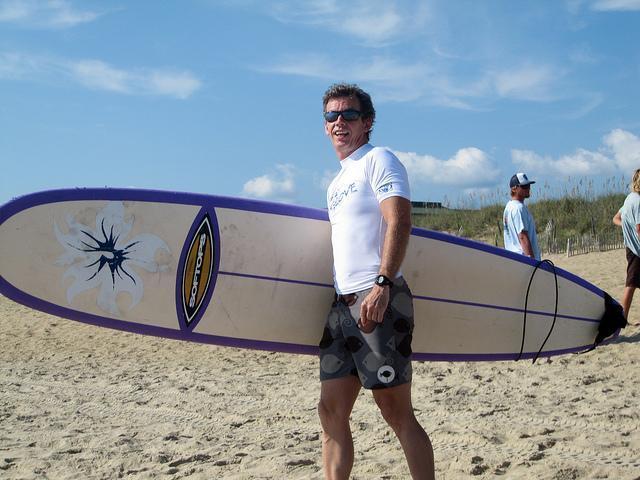How many surfboards are in the picture?
Give a very brief answer. 1. How many men are bald?
Give a very brief answer. 0. How many people are there?
Give a very brief answer. 2. How many trains are there?
Give a very brief answer. 0. 